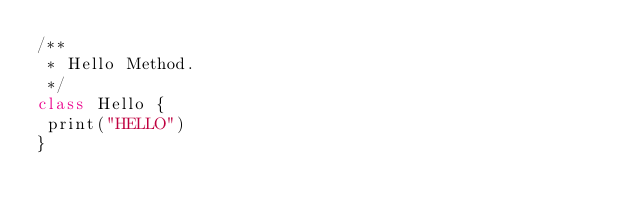<code> <loc_0><loc_0><loc_500><loc_500><_Scala_>/**
 * Hello Method.
 */
class Hello {
 print("HELLO")
}
</code> 